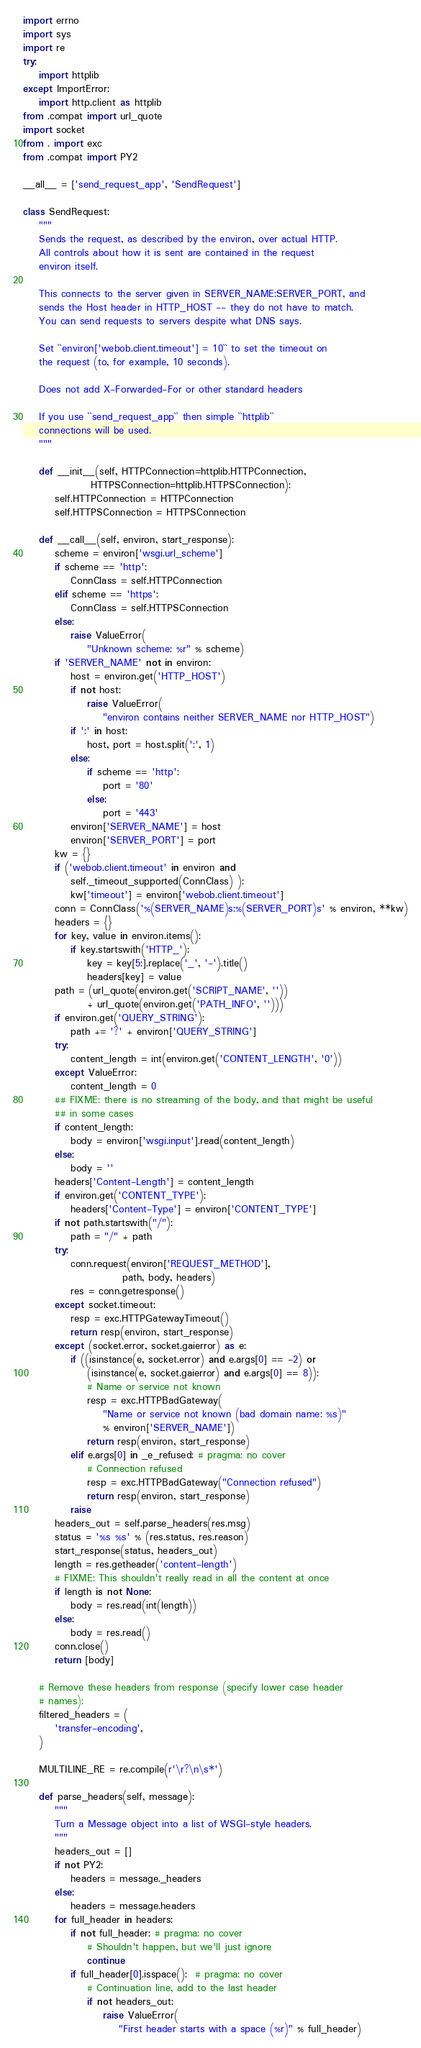<code> <loc_0><loc_0><loc_500><loc_500><_Python_>import errno
import sys
import re
try:
    import httplib
except ImportError:
    import http.client as httplib
from .compat import url_quote
import socket
from . import exc
from .compat import PY2

__all__ = ['send_request_app', 'SendRequest']

class SendRequest:
    """
    Sends the request, as described by the environ, over actual HTTP.
    All controls about how it is sent are contained in the request
    environ itself.

    This connects to the server given in SERVER_NAME:SERVER_PORT, and
    sends the Host header in HTTP_HOST -- they do not have to match.
    You can send requests to servers despite what DNS says.

    Set ``environ['webob.client.timeout'] = 10`` to set the timeout on
    the request (to, for example, 10 seconds).

    Does not add X-Forwarded-For or other standard headers

    If you use ``send_request_app`` then simple ``httplib``
    connections will be used.
    """

    def __init__(self, HTTPConnection=httplib.HTTPConnection,
                 HTTPSConnection=httplib.HTTPSConnection):
        self.HTTPConnection = HTTPConnection
        self.HTTPSConnection = HTTPSConnection

    def __call__(self, environ, start_response):
        scheme = environ['wsgi.url_scheme']
        if scheme == 'http':
            ConnClass = self.HTTPConnection
        elif scheme == 'https':
            ConnClass = self.HTTPSConnection
        else:
            raise ValueError(
                "Unknown scheme: %r" % scheme)
        if 'SERVER_NAME' not in environ:
            host = environ.get('HTTP_HOST')
            if not host:
                raise ValueError(
                    "environ contains neither SERVER_NAME nor HTTP_HOST")
            if ':' in host:
                host, port = host.split(':', 1)
            else:
                if scheme == 'http':
                    port = '80'
                else:
                    port = '443'
            environ['SERVER_NAME'] = host
            environ['SERVER_PORT'] = port
        kw = {}
        if ('webob.client.timeout' in environ and
            self._timeout_supported(ConnClass) ):
            kw['timeout'] = environ['webob.client.timeout']
        conn = ConnClass('%(SERVER_NAME)s:%(SERVER_PORT)s' % environ, **kw)
        headers = {}
        for key, value in environ.items():
            if key.startswith('HTTP_'):
                key = key[5:].replace('_', '-').title()
                headers[key] = value
        path = (url_quote(environ.get('SCRIPT_NAME', ''))
                + url_quote(environ.get('PATH_INFO', '')))
        if environ.get('QUERY_STRING'):
            path += '?' + environ['QUERY_STRING']
        try:
            content_length = int(environ.get('CONTENT_LENGTH', '0'))
        except ValueError:
            content_length = 0
        ## FIXME: there is no streaming of the body, and that might be useful
        ## in some cases
        if content_length:
            body = environ['wsgi.input'].read(content_length)
        else:
            body = ''
        headers['Content-Length'] = content_length
        if environ.get('CONTENT_TYPE'):
            headers['Content-Type'] = environ['CONTENT_TYPE']
        if not path.startswith("/"):
            path = "/" + path
        try:
            conn.request(environ['REQUEST_METHOD'],
                         path, body, headers)
            res = conn.getresponse()
        except socket.timeout:
            resp = exc.HTTPGatewayTimeout()
            return resp(environ, start_response)
        except (socket.error, socket.gaierror) as e:
            if ((isinstance(e, socket.error) and e.args[0] == -2) or
                (isinstance(e, socket.gaierror) and e.args[0] == 8)):
                # Name or service not known
                resp = exc.HTTPBadGateway(
                    "Name or service not known (bad domain name: %s)"
                    % environ['SERVER_NAME'])
                return resp(environ, start_response)
            elif e.args[0] in _e_refused: # pragma: no cover
                # Connection refused
                resp = exc.HTTPBadGateway("Connection refused")
                return resp(environ, start_response)
            raise
        headers_out = self.parse_headers(res.msg)
        status = '%s %s' % (res.status, res.reason)
        start_response(status, headers_out)
        length = res.getheader('content-length')
        # FIXME: This shouldn't really read in all the content at once
        if length is not None:
            body = res.read(int(length))
        else:
            body = res.read()
        conn.close()
        return [body]

    # Remove these headers from response (specify lower case header
    # names):
    filtered_headers = (
        'transfer-encoding',
    )

    MULTILINE_RE = re.compile(r'\r?\n\s*')

    def parse_headers(self, message):
        """
        Turn a Message object into a list of WSGI-style headers.
        """
        headers_out = []
        if not PY2:
            headers = message._headers
        else:
            headers = message.headers
        for full_header in headers:
            if not full_header: # pragma: no cover
                # Shouldn't happen, but we'll just ignore
                continue
            if full_header[0].isspace():  # pragma: no cover
                # Continuation line, add to the last header
                if not headers_out:
                    raise ValueError(
                        "First header starts with a space (%r)" % full_header)</code> 